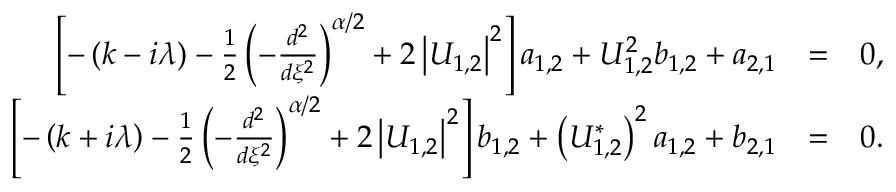<formula> <loc_0><loc_0><loc_500><loc_500>\begin{array} { r l r } { \left [ - \left ( k - i \lambda \right ) - \frac { 1 } { 2 } \left ( - \frac { d ^ { 2 } } { d \xi ^ { 2 } } \right ) ^ { \alpha / 2 } + 2 \left | U _ { 1 , 2 } \right | ^ { 2 } \right ] a _ { 1 , 2 } + U _ { 1 , 2 } ^ { 2 } b _ { 1 , 2 } + a _ { 2 , 1 } } & { = } & { 0 , } \\ { \left [ - \left ( k + i \lambda \right ) - \frac { 1 } { 2 } \left ( - \frac { d ^ { 2 } } { d \xi ^ { 2 } } \right ) ^ { \alpha / 2 } + 2 \left | U _ { 1 , 2 } \right | ^ { 2 } \right ] b _ { 1 , 2 } + \left ( U _ { 1 , 2 } ^ { \ast } \right ) ^ { 2 } a _ { 1 , 2 } + b _ { 2 , 1 } } & { = } & { 0 . } \end{array}</formula> 